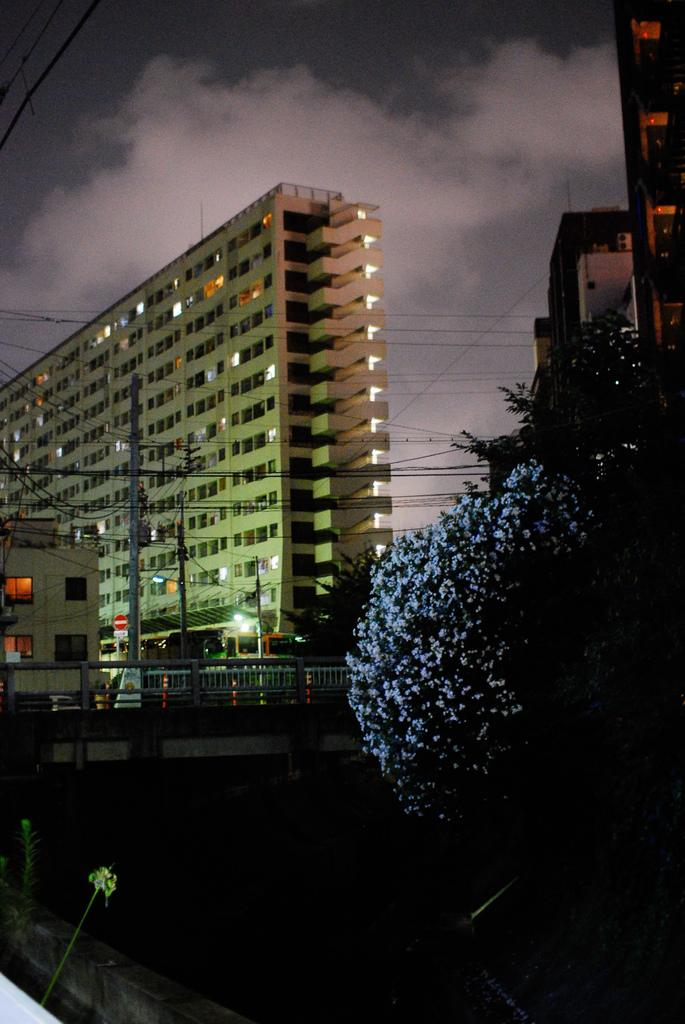What type of vegetation can be seen on the tree in the image? There are flowers on the tree in the image. What type of structures are visible in the image? There are buildings and a bridge in the image. What type of infrastructure is present in the image? There are electrical wire poles in the image. What is the condition of the sky in the image? The sky is cloudy in the image. How far away is the fan from the bridge in the image? There is no fan present in the image. Can you tell me how many people are walking on the bridge in the image? There is no indication of people walking on the bridge in the image. 